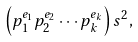Convert formula to latex. <formula><loc_0><loc_0><loc_500><loc_500>\left ( p _ { 1 } ^ { e _ { 1 } } p _ { 2 } ^ { e _ { 2 } } \cdots p _ { k } ^ { e _ { k } } \right ) s ^ { 2 } ,</formula> 